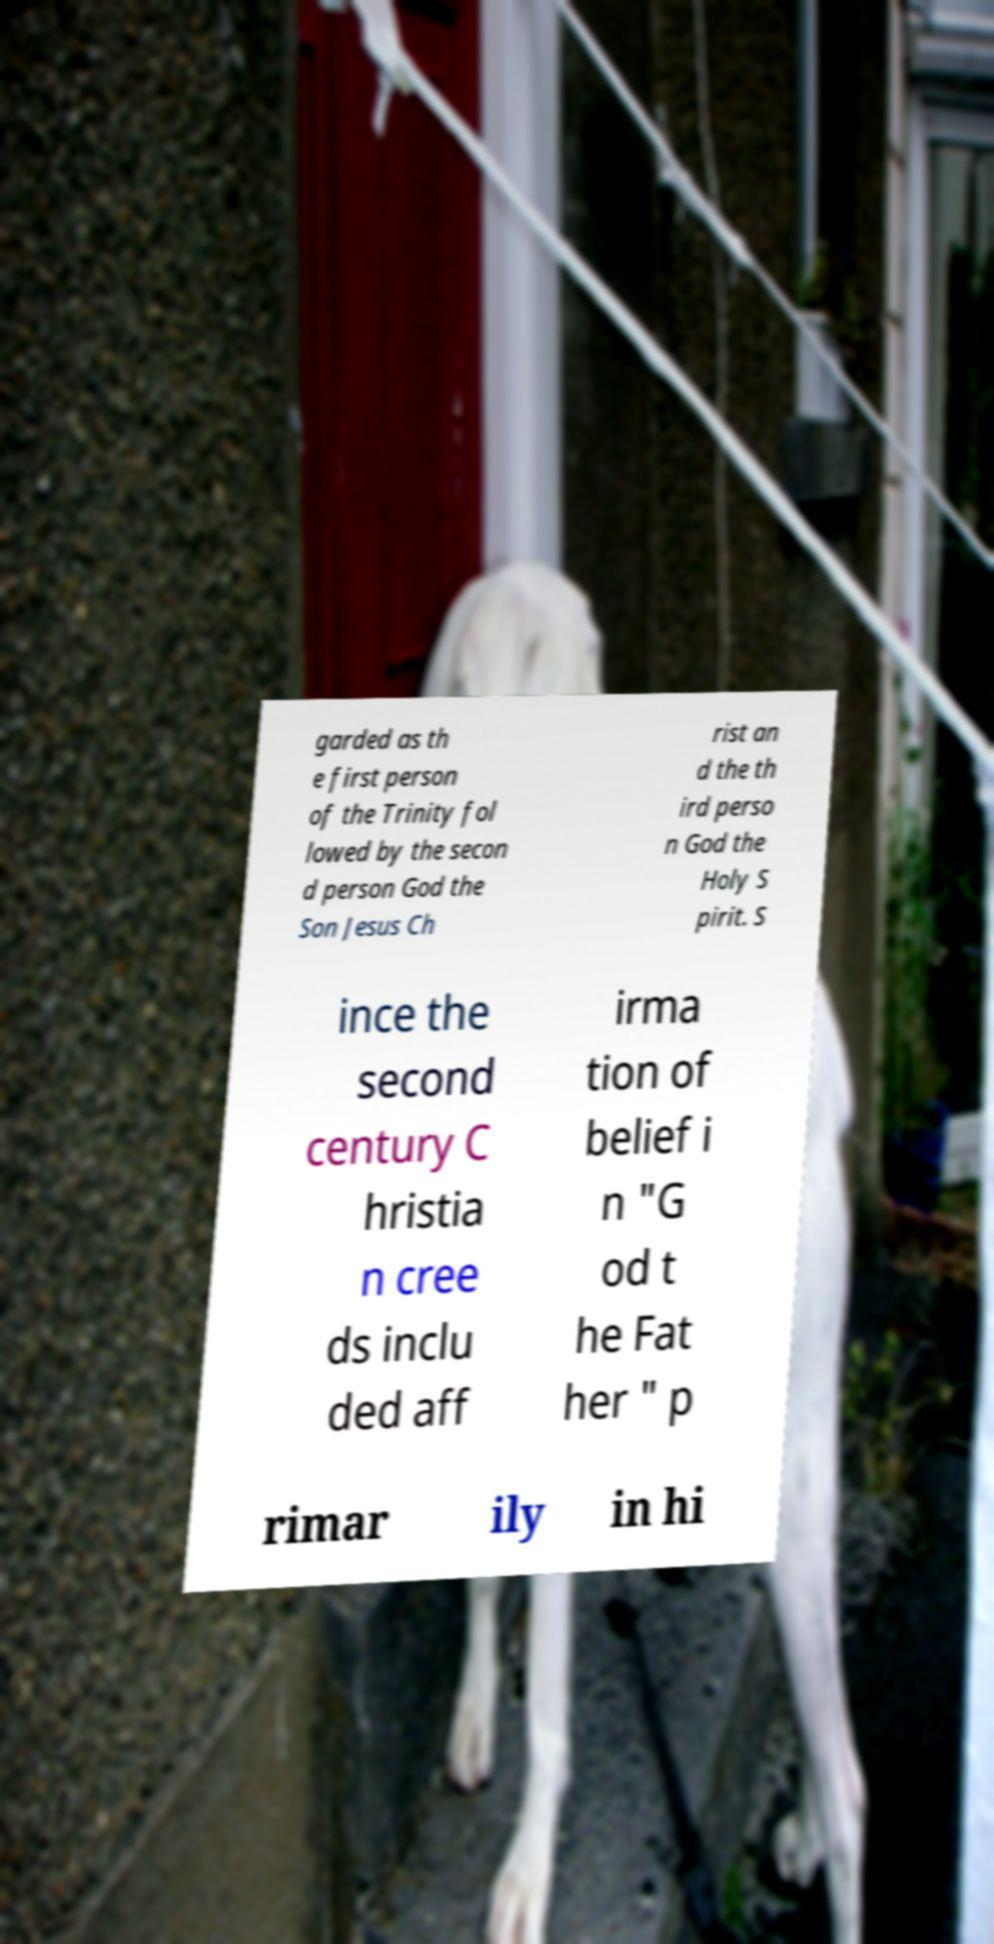There's text embedded in this image that I need extracted. Can you transcribe it verbatim? garded as th e first person of the Trinity fol lowed by the secon d person God the Son Jesus Ch rist an d the th ird perso n God the Holy S pirit. S ince the second century C hristia n cree ds inclu ded aff irma tion of belief i n "G od t he Fat her " p rimar ily in hi 